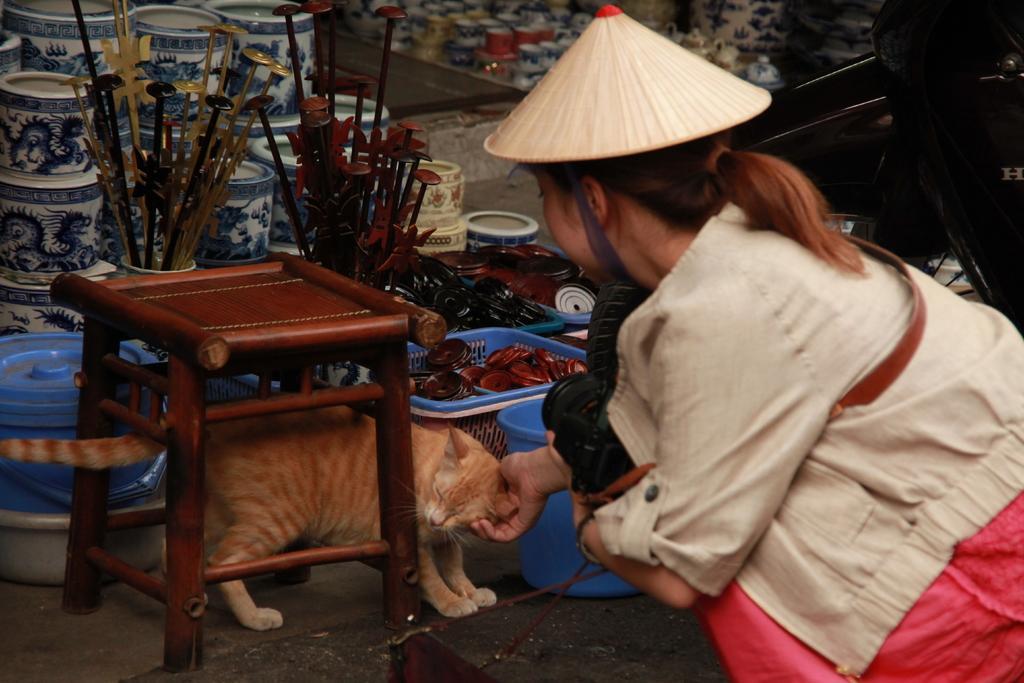How would you summarize this image in a sentence or two? In front of this picture, we see a girl wearing white jacket and hat on her head is catching cat in her hands and playing with it. To the right, to the left corner of the picture, we see table and beside that, we see basket which contains some kids in it and behind that, we see flower pots and some boxes which are white in color. 